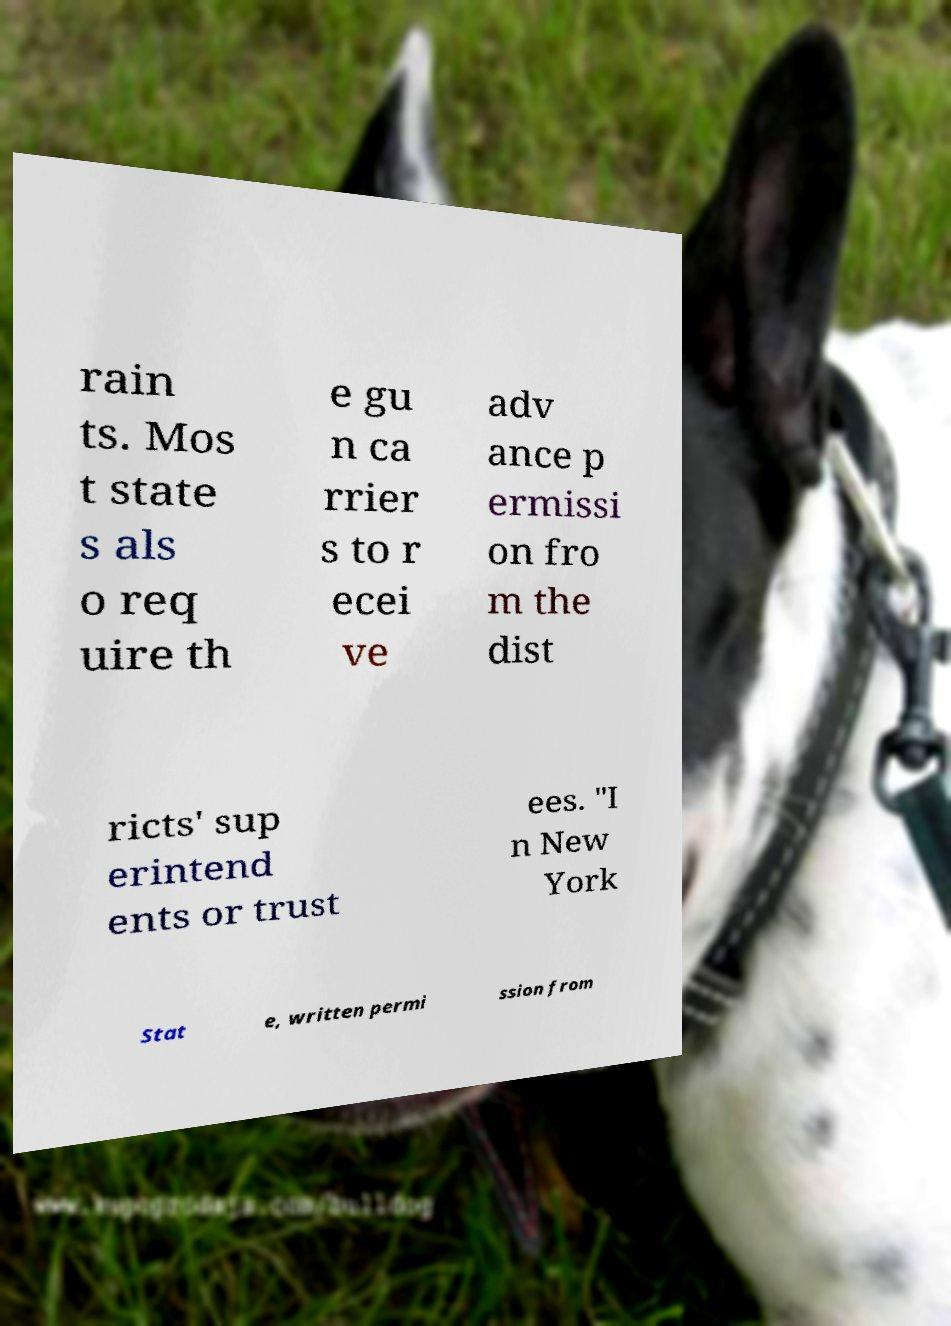Could you extract and type out the text from this image? rain ts. Mos t state s als o req uire th e gu n ca rrier s to r ecei ve adv ance p ermissi on fro m the dist ricts' sup erintend ents or trust ees. "I n New York Stat e, written permi ssion from 